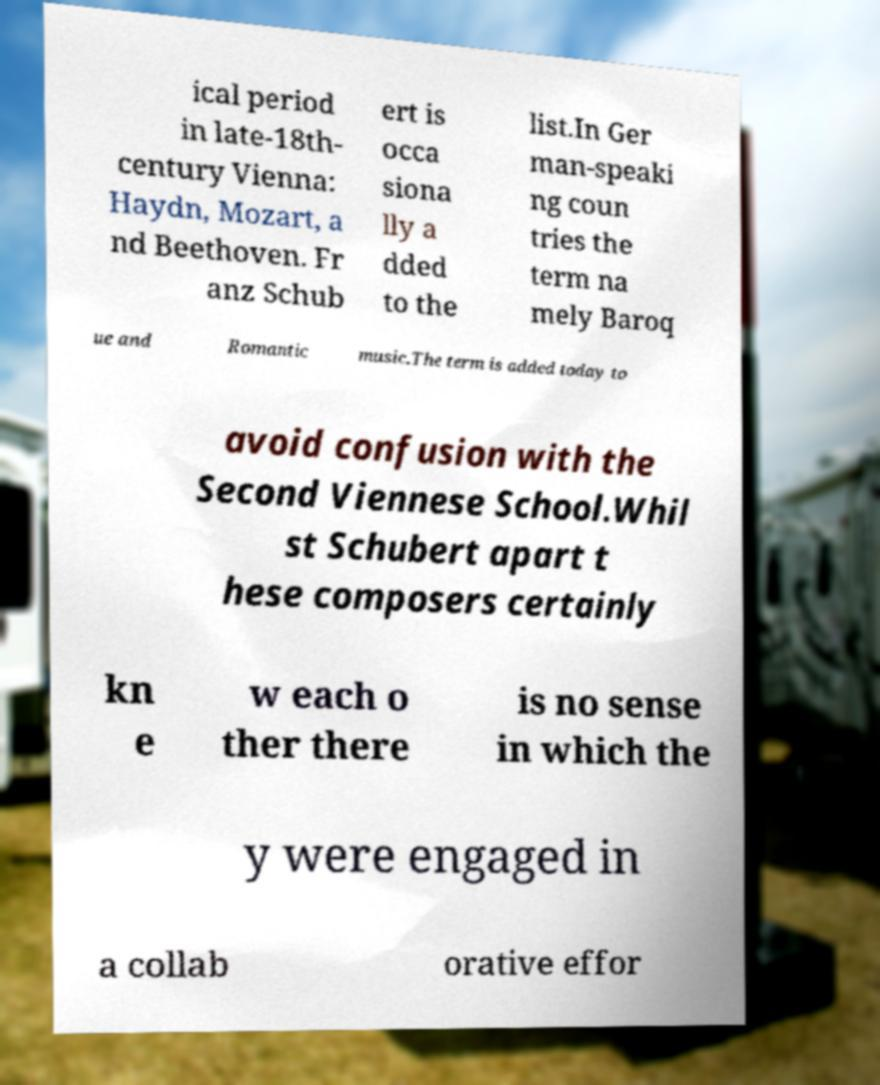Could you assist in decoding the text presented in this image and type it out clearly? ical period in late-18th- century Vienna: Haydn, Mozart, a nd Beethoven. Fr anz Schub ert is occa siona lly a dded to the list.In Ger man-speaki ng coun tries the term na mely Baroq ue and Romantic music.The term is added today to avoid confusion with the Second Viennese School.Whil st Schubert apart t hese composers certainly kn e w each o ther there is no sense in which the y were engaged in a collab orative effor 